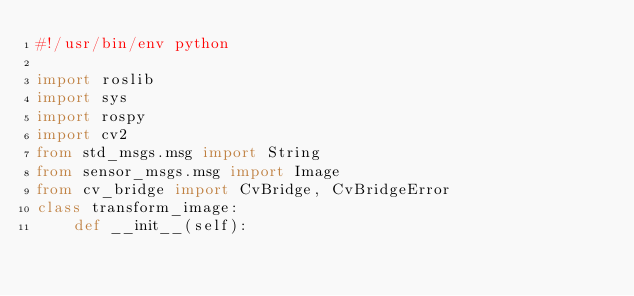Convert code to text. <code><loc_0><loc_0><loc_500><loc_500><_Python_>#!/usr/bin/env python 

import roslib 
import sys 
import rospy 
import cv2 
from std_msgs.msg import String 
from sensor_msgs.msg import Image 
from cv_bridge import CvBridge, CvBridgeError 
class transform_image: 
	def __init__(self): </code> 